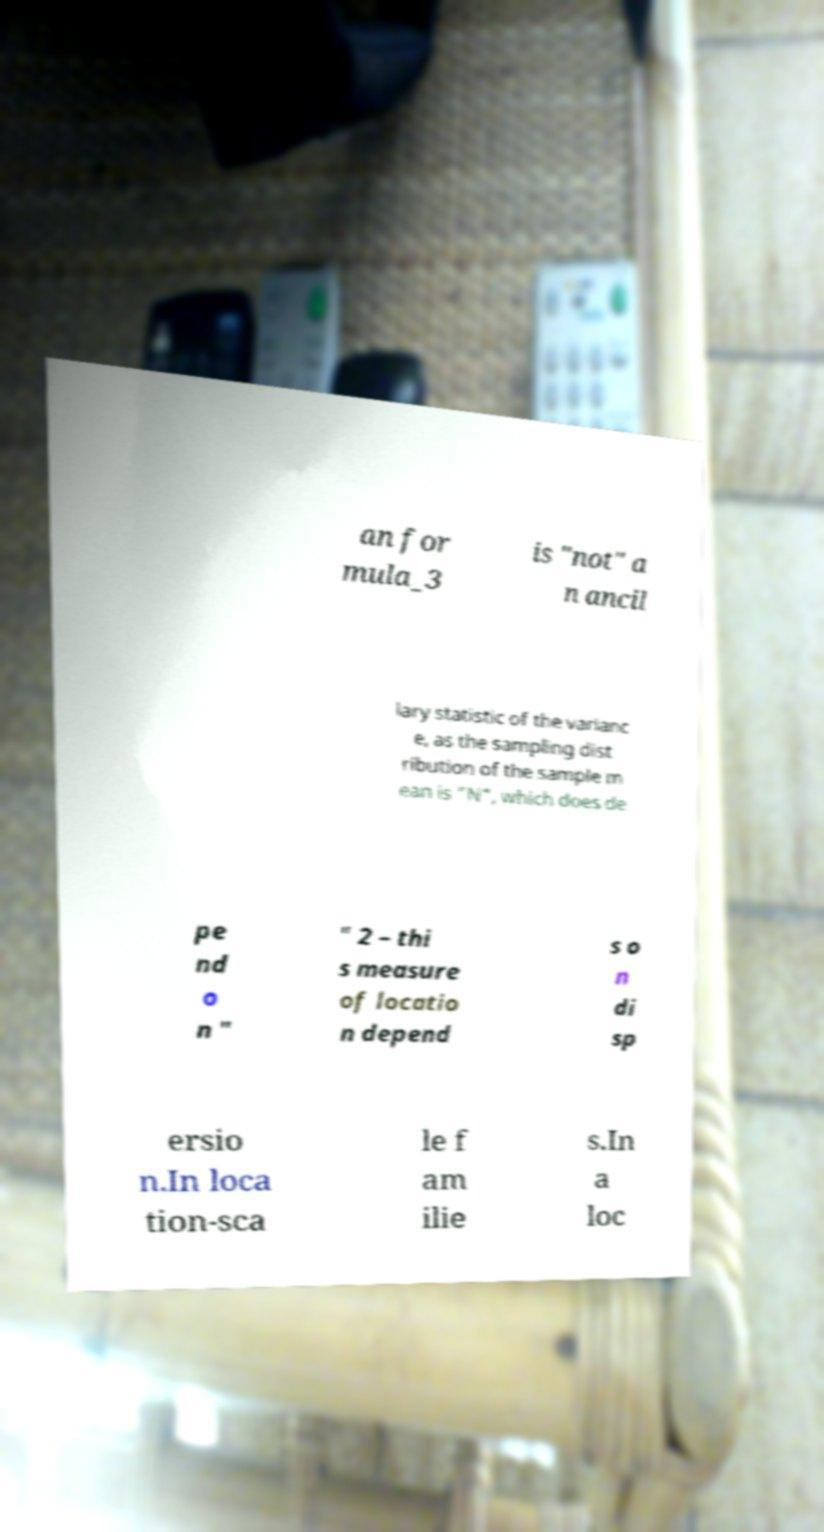For documentation purposes, I need the text within this image transcribed. Could you provide that? an for mula_3 is "not" a n ancil lary statistic of the varianc e, as the sampling dist ribution of the sample m ean is "N", which does de pe nd o n " " 2 – thi s measure of locatio n depend s o n di sp ersio n.In loca tion-sca le f am ilie s.In a loc 